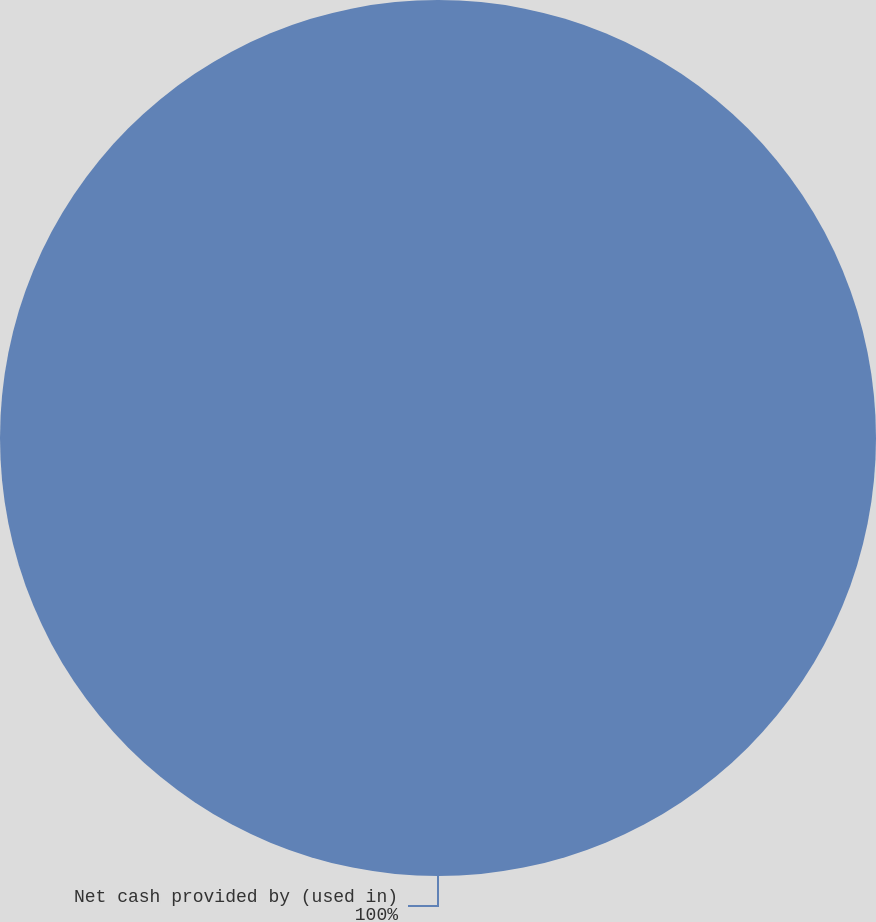<chart> <loc_0><loc_0><loc_500><loc_500><pie_chart><fcel>Net cash provided by (used in)<nl><fcel>100.0%<nl></chart> 